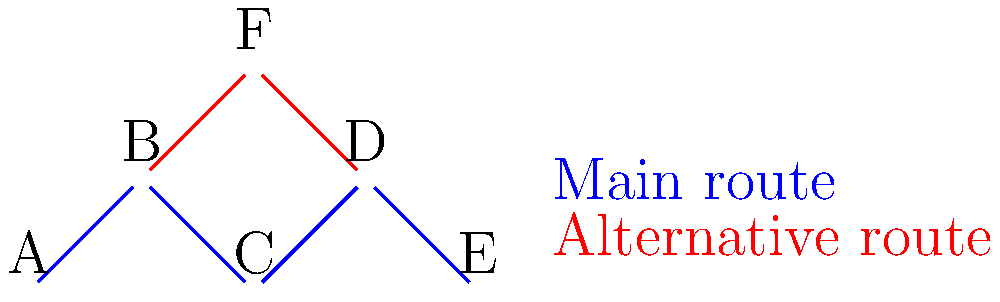Based on the simplified map of Groningen's main cycling routes, what is the minimum number of intersections a cyclist must pass through to travel from point A to point E using only the main route (blue)? To solve this problem, we need to follow these steps:

1. Identify the main route (blue) from point A to point E.
2. Count the number of intersections along this route.

Step 1: Identifying the main route
The main route (blue) from A to E passes through the following points:
A → B → C → D → E

Step 2: Counting intersections
An intersection is a point where two or more routes meet. In this case, we need to count the points where the cyclist passes through, excluding the starting and ending points:

- Point B: This is an intersection as the alternative route (red) meets the main route here.
- Point C: This is not an intersection as only the main route passes through it.
- Point D: This is an intersection as the alternative route meets the main route here.

Therefore, the cyclist passes through 2 intersections (B and D) when traveling from A to E using only the main route.
Answer: 2 intersections 